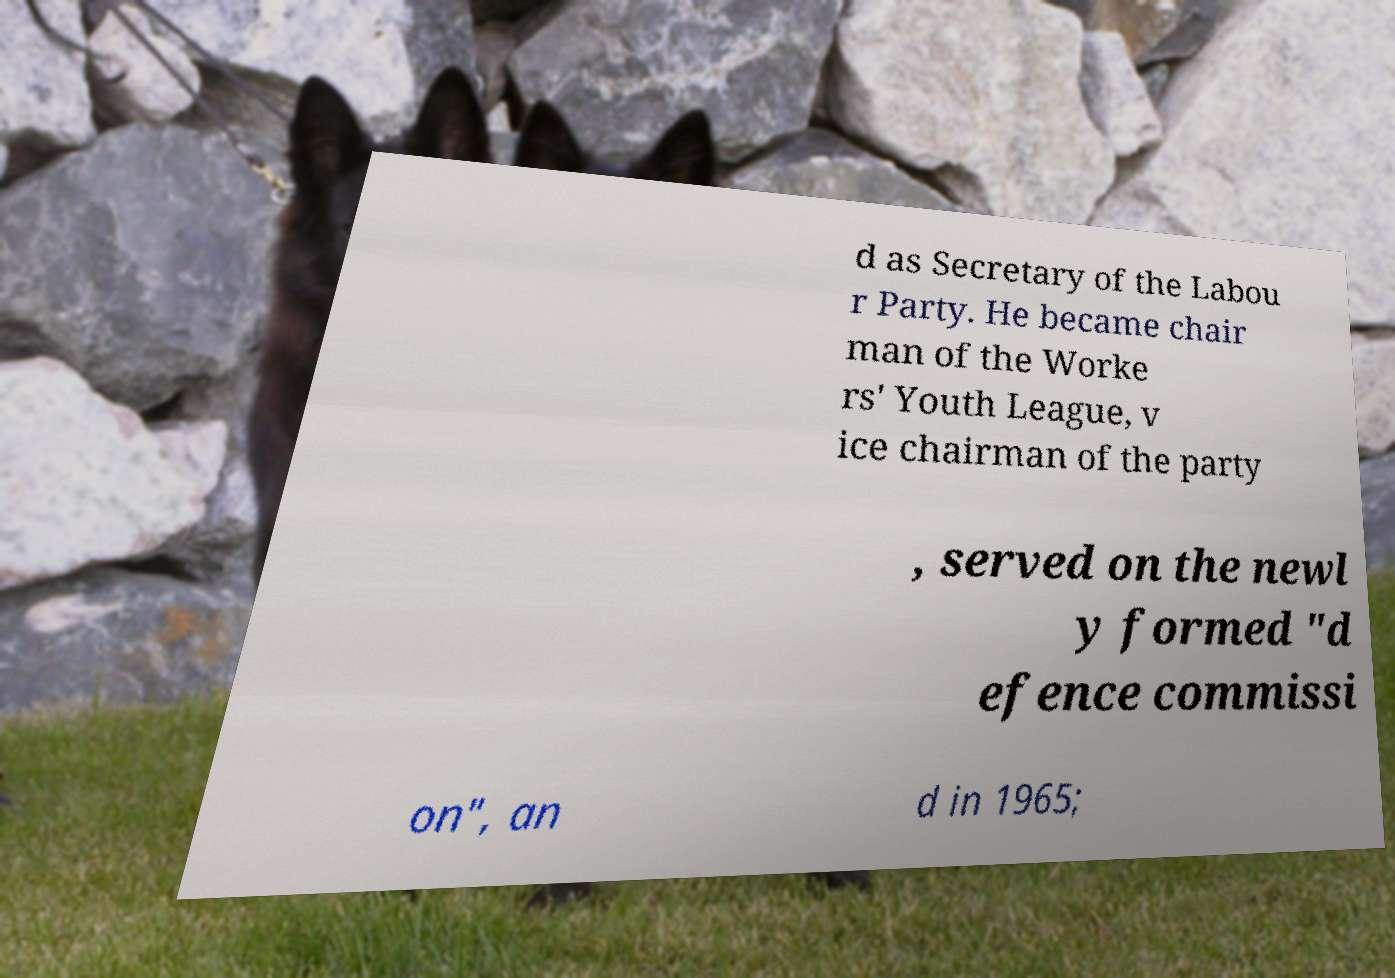Please identify and transcribe the text found in this image. d as Secretary of the Labou r Party. He became chair man of the Worke rs' Youth League, v ice chairman of the party , served on the newl y formed "d efence commissi on", an d in 1965; 